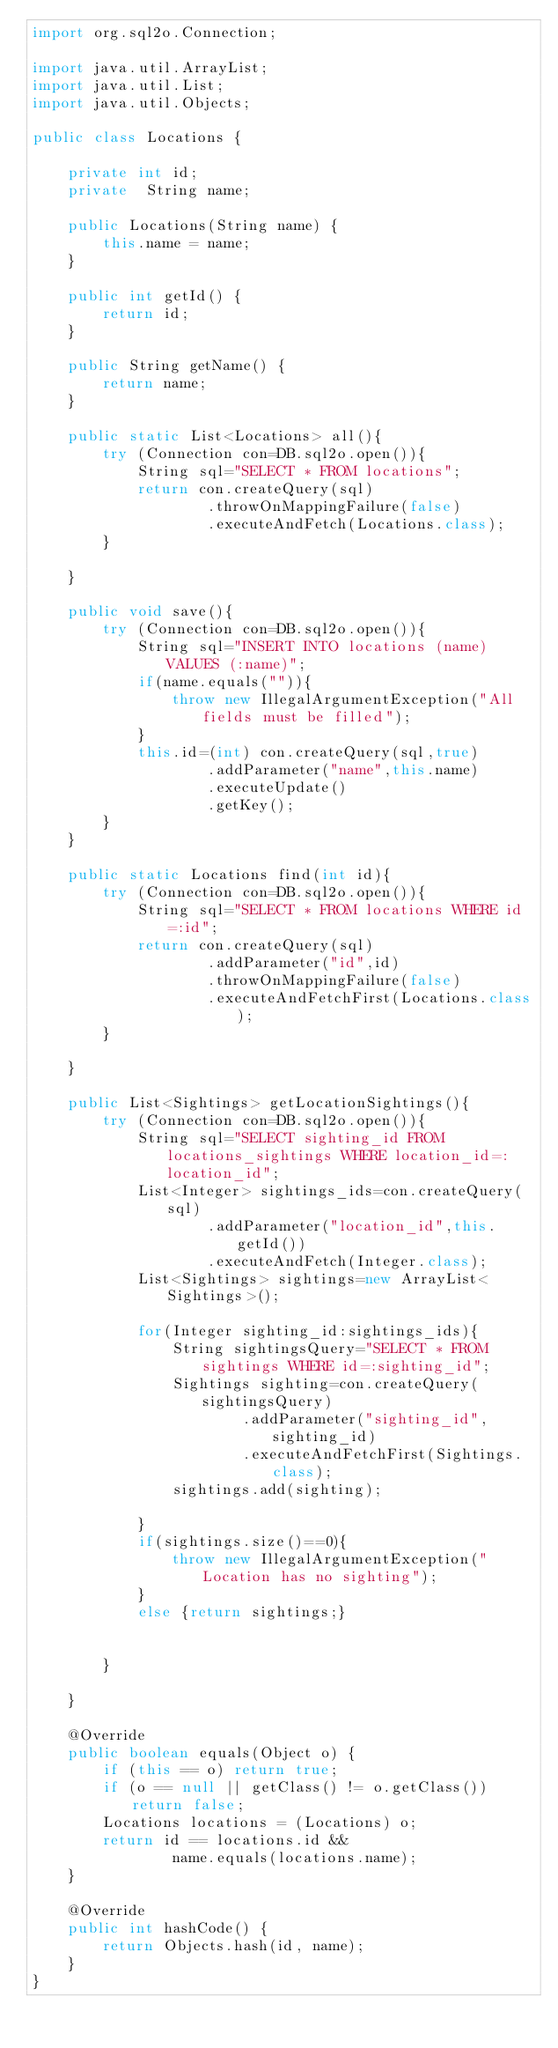Convert code to text. <code><loc_0><loc_0><loc_500><loc_500><_Java_>import org.sql2o.Connection;

import java.util.ArrayList;
import java.util.List;
import java.util.Objects;

public class Locations {

    private int id;
    private  String name;

    public Locations(String name) {
        this.name = name;
    }

    public int getId() {
        return id;
    }

    public String getName() {
        return name;
    }

    public static List<Locations> all(){
        try (Connection con=DB.sql2o.open()){
            String sql="SELECT * FROM locations";
            return con.createQuery(sql)
                    .throwOnMappingFailure(false)
                    .executeAndFetch(Locations.class);
        }

    }

    public void save(){
        try (Connection con=DB.sql2o.open()){
            String sql="INSERT INTO locations (name) VALUES (:name)";
            if(name.equals("")){
                throw new IllegalArgumentException("All fields must be filled");
            }
            this.id=(int) con.createQuery(sql,true)
                    .addParameter("name",this.name)
                    .executeUpdate()
                    .getKey();
        }
    }

    public static Locations find(int id){
        try (Connection con=DB.sql2o.open()){
            String sql="SELECT * FROM locations WHERE id=:id";
            return con.createQuery(sql)
                    .addParameter("id",id)
                    .throwOnMappingFailure(false)
                    .executeAndFetchFirst(Locations.class);
        }

    }

    public List<Sightings> getLocationSightings(){
        try (Connection con=DB.sql2o.open()){
            String sql="SELECT sighting_id FROM locations_sightings WHERE location_id=:location_id";
            List<Integer> sightings_ids=con.createQuery(sql)
                    .addParameter("location_id",this.getId())
                    .executeAndFetch(Integer.class);
            List<Sightings> sightings=new ArrayList<Sightings>();

            for(Integer sighting_id:sightings_ids){
                String sightingsQuery="SELECT * FROM sightings WHERE id=:sighting_id";
                Sightings sighting=con.createQuery(sightingsQuery)
                        .addParameter("sighting_id",sighting_id)
                        .executeAndFetchFirst(Sightings.class);
                sightings.add(sighting);

            }
            if(sightings.size()==0){
                throw new IllegalArgumentException("Location has no sighting");
            }
            else {return sightings;}


        }

    }

    @Override
    public boolean equals(Object o) {
        if (this == o) return true;
        if (o == null || getClass() != o.getClass()) return false;
        Locations locations = (Locations) o;
        return id == locations.id &&
                name.equals(locations.name);
    }

    @Override
    public int hashCode() {
        return Objects.hash(id, name);
    }
}</code> 